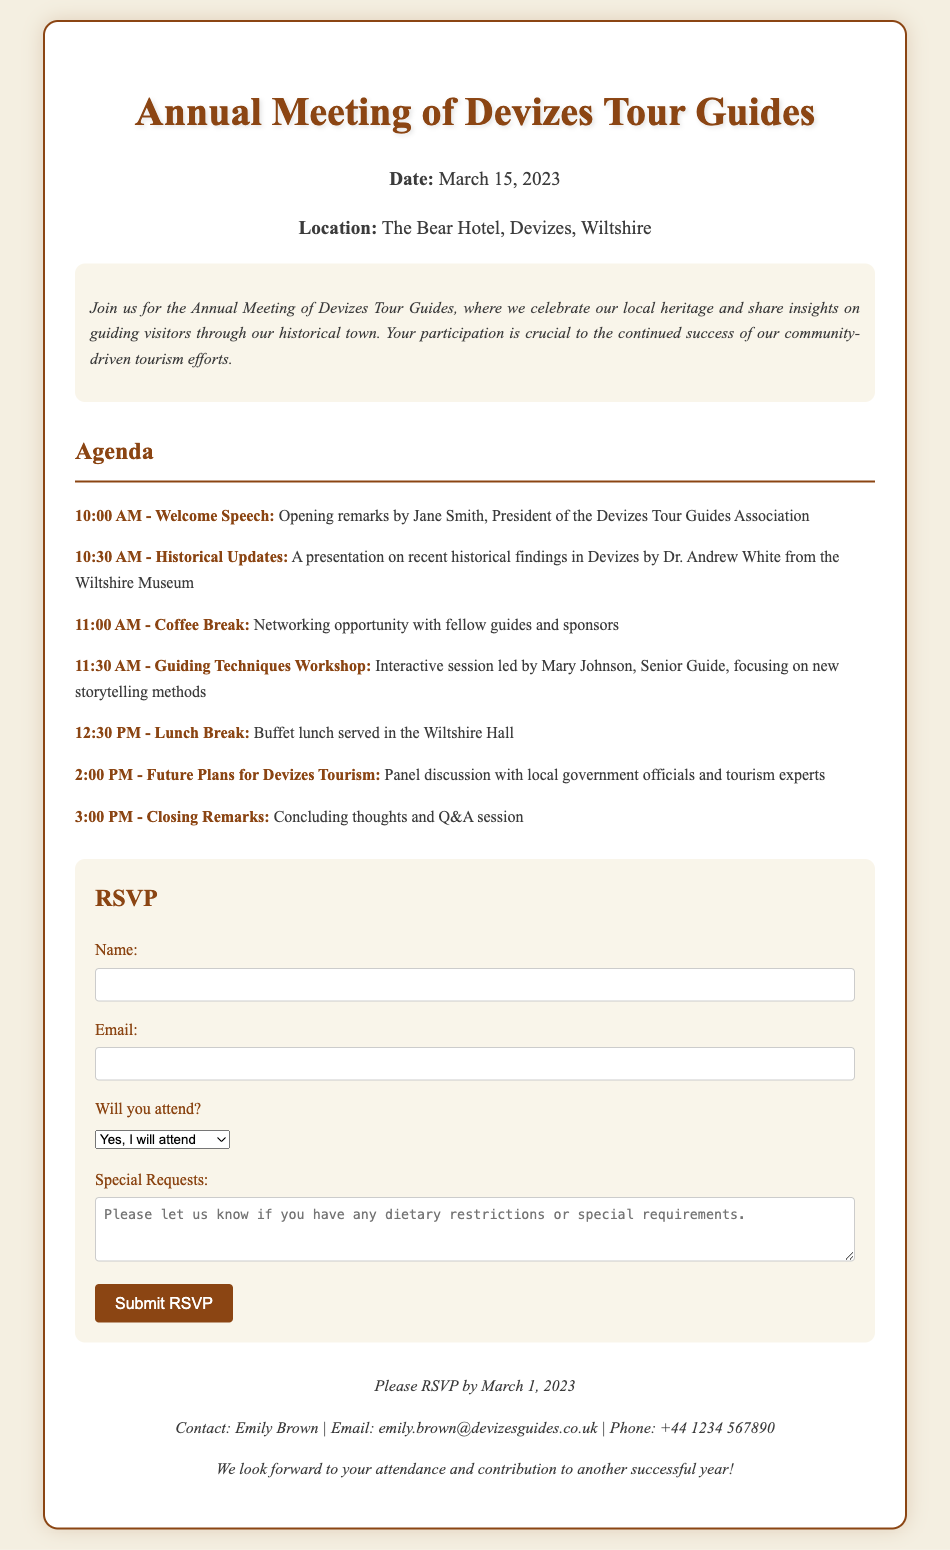What is the date of the meeting? The date of the meeting is explicitly mentioned in the event details section.
Answer: March 15, 2023 Where is the meeting located? The location of the meeting is specified in the event details section.
Answer: The Bear Hotel, Devizes, Wiltshire Who is giving the welcome speech? The agenda lists the person responsible for the welcome speech.
Answer: Jane Smith What time does the Coffee Break start? The agenda specifies the start time of the Coffee Break.
Answer: 11:00 AM What type of workshop is scheduled before lunch? The agenda describes the nature of the workshop.
Answer: Guiding Techniques Workshop How can attendees submit special requests? The RSVP form section mentions where attendees can provide special requests.
Answer: In the Special Requests textarea Who should attendees contact for more information? The footer provides contact information for inquiries.
Answer: Emily Brown When is the RSVP deadline? The footer highlights the deadline for submitting the RSVP.
Answer: March 1, 2023 Will there be a panel discussion? The agenda indicates the presence of a panel discussion and its time.
Answer: Yes, at 2:00 PM 